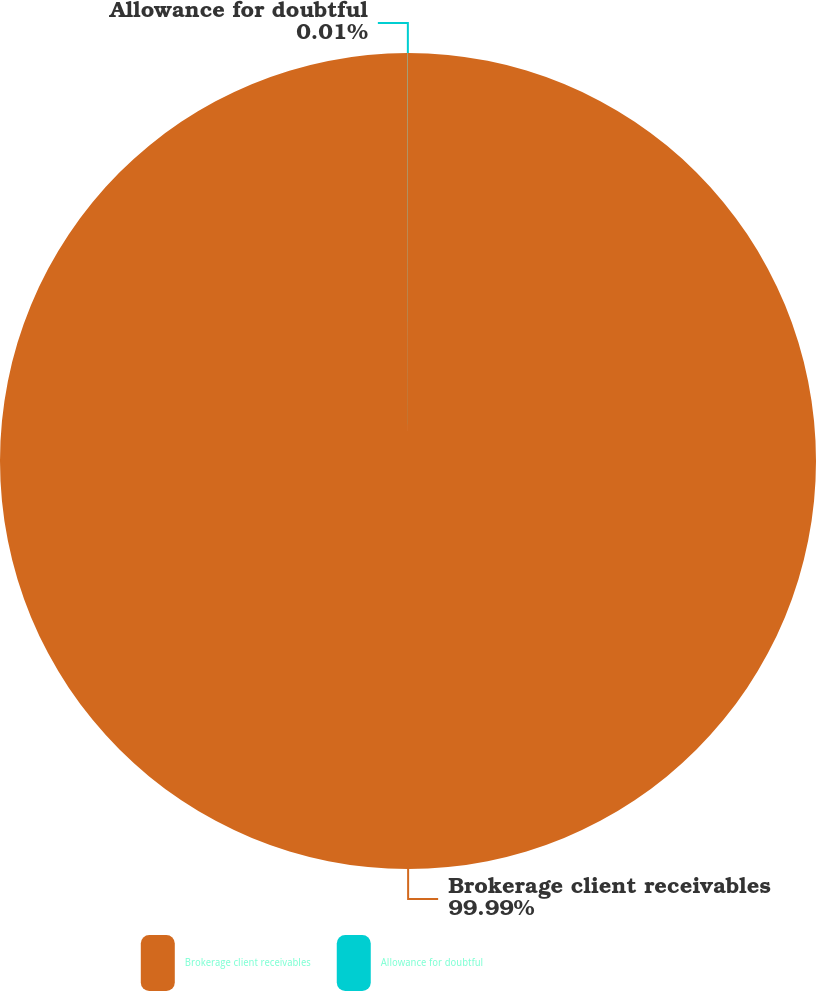<chart> <loc_0><loc_0><loc_500><loc_500><pie_chart><fcel>Brokerage client receivables<fcel>Allowance for doubtful<nl><fcel>99.99%<fcel>0.01%<nl></chart> 